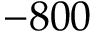Convert formula to latex. <formula><loc_0><loc_0><loc_500><loc_500>- 8 0 0</formula> 